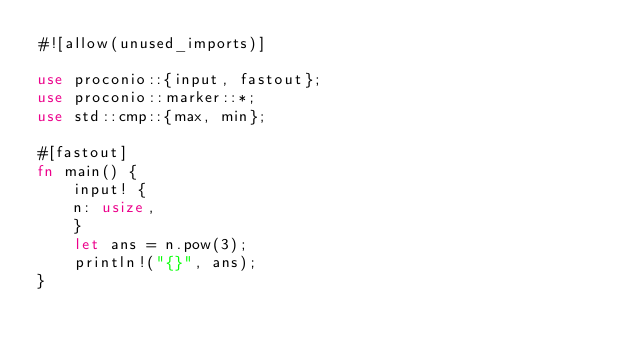<code> <loc_0><loc_0><loc_500><loc_500><_Rust_>#![allow(unused_imports)]

use proconio::{input, fastout};
use proconio::marker::*;
use std::cmp::{max, min};

#[fastout]
fn main() {
    input! {
    n: usize,
    }
    let ans = n.pow(3);
    println!("{}", ans);
}
</code> 